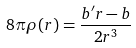<formula> <loc_0><loc_0><loc_500><loc_500>8 \pi \rho ( r ) = \frac { b ^ { \prime } r - b } { 2 r ^ { 3 } }</formula> 